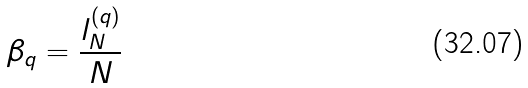<formula> <loc_0><loc_0><loc_500><loc_500>\, \beta _ { q } = \frac { l _ { N } ^ { ( q ) } } N</formula> 